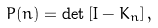<formula> <loc_0><loc_0><loc_500><loc_500>P ( n ) = \det \left [ I - K _ { n } \right ] ,</formula> 